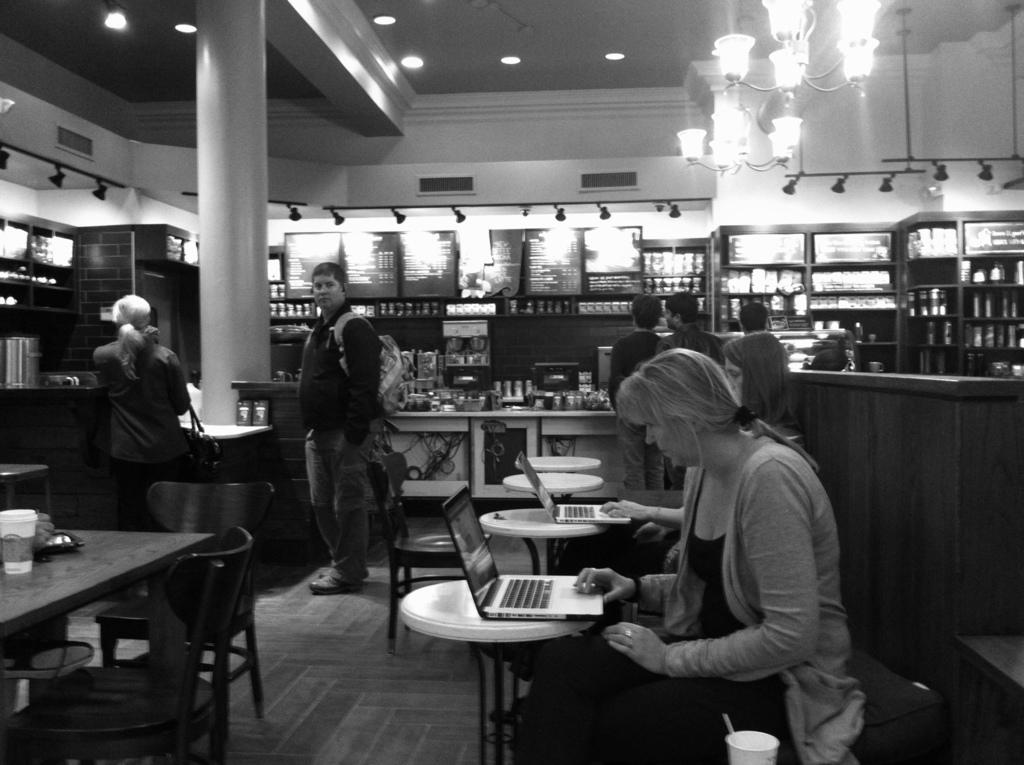What type of furniture is present in the image? There are tables and chairs in the image. What are the people in the image doing? People are sitting on the chairs. What can be found on the shelves in the image? There are items placed on the shelves. How many lamps are visible in the image? There are two lamps in the image. What type of plastic material can be seen covering the yam in the image? There is no yam or plastic material present in the image. Is there a rat visible in the image? No, there is no rat present in the image. 